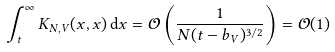Convert formula to latex. <formula><loc_0><loc_0><loc_500><loc_500>\int _ { t } ^ { \infty } K _ { N , V } ( x , x ) \, { \mathrm d } x = \mathcal { O } \left ( \frac { 1 } { N ( t - b _ { V } ) ^ { 3 / 2 } } \right ) = \mathcal { O } ( 1 )</formula> 